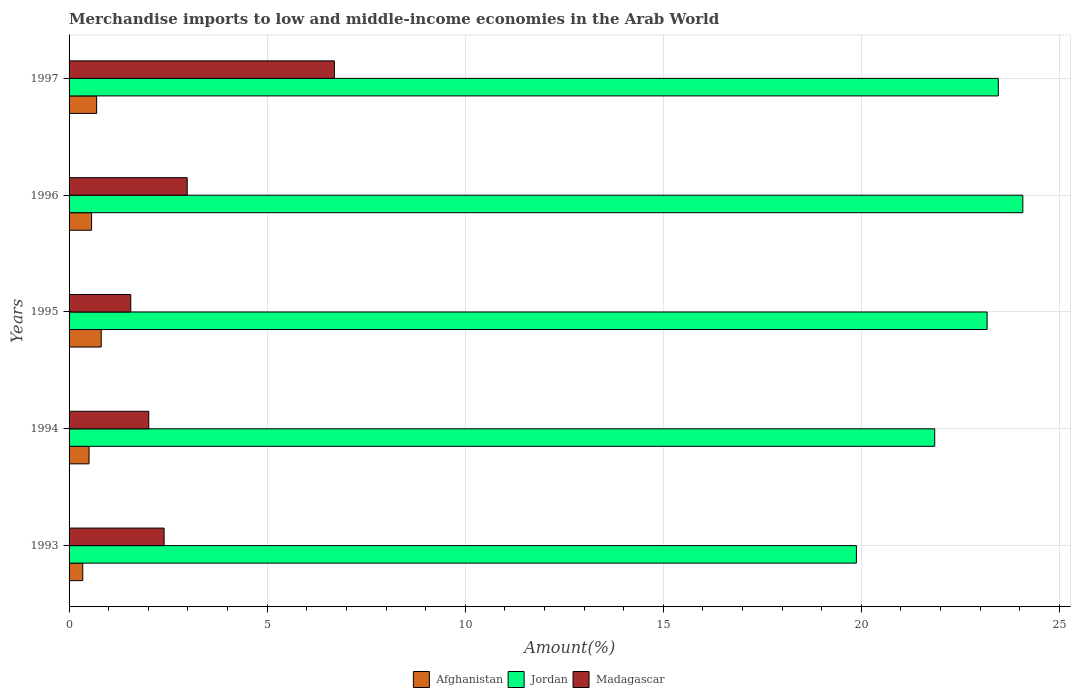Are the number of bars per tick equal to the number of legend labels?
Your response must be concise. Yes. In how many cases, is the number of bars for a given year not equal to the number of legend labels?
Your response must be concise. 0. What is the percentage of amount earned from merchandise imports in Jordan in 1996?
Offer a terse response. 24.07. Across all years, what is the maximum percentage of amount earned from merchandise imports in Afghanistan?
Provide a short and direct response. 0.81. Across all years, what is the minimum percentage of amount earned from merchandise imports in Madagascar?
Your answer should be very brief. 1.56. In which year was the percentage of amount earned from merchandise imports in Jordan maximum?
Your response must be concise. 1996. What is the total percentage of amount earned from merchandise imports in Madagascar in the graph?
Offer a terse response. 15.65. What is the difference between the percentage of amount earned from merchandise imports in Jordan in 1995 and that in 1996?
Make the answer very short. -0.9. What is the difference between the percentage of amount earned from merchandise imports in Jordan in 1994 and the percentage of amount earned from merchandise imports in Afghanistan in 1996?
Keep it short and to the point. 21.28. What is the average percentage of amount earned from merchandise imports in Jordan per year?
Provide a succinct answer. 22.49. In the year 1994, what is the difference between the percentage of amount earned from merchandise imports in Madagascar and percentage of amount earned from merchandise imports in Jordan?
Make the answer very short. -19.84. In how many years, is the percentage of amount earned from merchandise imports in Jordan greater than 4 %?
Make the answer very short. 5. What is the ratio of the percentage of amount earned from merchandise imports in Afghanistan in 1993 to that in 1996?
Give a very brief answer. 0.61. What is the difference between the highest and the second highest percentage of amount earned from merchandise imports in Jordan?
Your answer should be very brief. 0.62. What is the difference between the highest and the lowest percentage of amount earned from merchandise imports in Afghanistan?
Your response must be concise. 0.47. What does the 2nd bar from the top in 1994 represents?
Give a very brief answer. Jordan. What does the 1st bar from the bottom in 1993 represents?
Provide a short and direct response. Afghanistan. Is it the case that in every year, the sum of the percentage of amount earned from merchandise imports in Afghanistan and percentage of amount earned from merchandise imports in Madagascar is greater than the percentage of amount earned from merchandise imports in Jordan?
Your answer should be compact. No. Are all the bars in the graph horizontal?
Make the answer very short. Yes. How many years are there in the graph?
Give a very brief answer. 5. What is the difference between two consecutive major ticks on the X-axis?
Your answer should be compact. 5. Are the values on the major ticks of X-axis written in scientific E-notation?
Your answer should be very brief. No. Does the graph contain any zero values?
Offer a very short reply. No. Does the graph contain grids?
Make the answer very short. Yes. How are the legend labels stacked?
Offer a terse response. Horizontal. What is the title of the graph?
Provide a succinct answer. Merchandise imports to low and middle-income economies in the Arab World. What is the label or title of the X-axis?
Your answer should be compact. Amount(%). What is the Amount(%) of Afghanistan in 1993?
Give a very brief answer. 0.35. What is the Amount(%) of Jordan in 1993?
Provide a succinct answer. 19.87. What is the Amount(%) in Madagascar in 1993?
Make the answer very short. 2.4. What is the Amount(%) of Afghanistan in 1994?
Offer a very short reply. 0.5. What is the Amount(%) in Jordan in 1994?
Provide a succinct answer. 21.85. What is the Amount(%) of Madagascar in 1994?
Keep it short and to the point. 2.01. What is the Amount(%) in Afghanistan in 1995?
Keep it short and to the point. 0.81. What is the Amount(%) in Jordan in 1995?
Your response must be concise. 23.17. What is the Amount(%) of Madagascar in 1995?
Give a very brief answer. 1.56. What is the Amount(%) of Afghanistan in 1996?
Offer a very short reply. 0.57. What is the Amount(%) of Jordan in 1996?
Provide a short and direct response. 24.07. What is the Amount(%) in Madagascar in 1996?
Provide a succinct answer. 2.98. What is the Amount(%) in Afghanistan in 1997?
Keep it short and to the point. 0.7. What is the Amount(%) in Jordan in 1997?
Keep it short and to the point. 23.46. What is the Amount(%) in Madagascar in 1997?
Provide a short and direct response. 6.7. Across all years, what is the maximum Amount(%) in Afghanistan?
Offer a terse response. 0.81. Across all years, what is the maximum Amount(%) of Jordan?
Your answer should be compact. 24.07. Across all years, what is the maximum Amount(%) in Madagascar?
Offer a very short reply. 6.7. Across all years, what is the minimum Amount(%) of Afghanistan?
Your response must be concise. 0.35. Across all years, what is the minimum Amount(%) of Jordan?
Make the answer very short. 19.87. Across all years, what is the minimum Amount(%) in Madagascar?
Ensure brevity in your answer.  1.56. What is the total Amount(%) of Afghanistan in the graph?
Give a very brief answer. 2.93. What is the total Amount(%) in Jordan in the graph?
Ensure brevity in your answer.  112.43. What is the total Amount(%) in Madagascar in the graph?
Ensure brevity in your answer.  15.65. What is the difference between the Amount(%) in Afghanistan in 1993 and that in 1994?
Make the answer very short. -0.16. What is the difference between the Amount(%) of Jordan in 1993 and that in 1994?
Provide a short and direct response. -1.98. What is the difference between the Amount(%) in Madagascar in 1993 and that in 1994?
Keep it short and to the point. 0.39. What is the difference between the Amount(%) of Afghanistan in 1993 and that in 1995?
Make the answer very short. -0.47. What is the difference between the Amount(%) of Jordan in 1993 and that in 1995?
Ensure brevity in your answer.  -3.3. What is the difference between the Amount(%) in Madagascar in 1993 and that in 1995?
Your answer should be very brief. 0.84. What is the difference between the Amount(%) of Afghanistan in 1993 and that in 1996?
Make the answer very short. -0.22. What is the difference between the Amount(%) in Jordan in 1993 and that in 1996?
Keep it short and to the point. -4.2. What is the difference between the Amount(%) in Madagascar in 1993 and that in 1996?
Provide a succinct answer. -0.58. What is the difference between the Amount(%) in Afghanistan in 1993 and that in 1997?
Provide a short and direct response. -0.35. What is the difference between the Amount(%) in Jordan in 1993 and that in 1997?
Keep it short and to the point. -3.58. What is the difference between the Amount(%) of Madagascar in 1993 and that in 1997?
Give a very brief answer. -4.3. What is the difference between the Amount(%) of Afghanistan in 1994 and that in 1995?
Provide a succinct answer. -0.31. What is the difference between the Amount(%) of Jordan in 1994 and that in 1995?
Ensure brevity in your answer.  -1.32. What is the difference between the Amount(%) in Madagascar in 1994 and that in 1995?
Provide a succinct answer. 0.45. What is the difference between the Amount(%) in Afghanistan in 1994 and that in 1996?
Provide a short and direct response. -0.06. What is the difference between the Amount(%) of Jordan in 1994 and that in 1996?
Offer a very short reply. -2.22. What is the difference between the Amount(%) of Madagascar in 1994 and that in 1996?
Offer a terse response. -0.97. What is the difference between the Amount(%) of Afghanistan in 1994 and that in 1997?
Your answer should be compact. -0.19. What is the difference between the Amount(%) of Jordan in 1994 and that in 1997?
Offer a terse response. -1.6. What is the difference between the Amount(%) in Madagascar in 1994 and that in 1997?
Offer a terse response. -4.69. What is the difference between the Amount(%) of Afghanistan in 1995 and that in 1996?
Give a very brief answer. 0.24. What is the difference between the Amount(%) of Jordan in 1995 and that in 1996?
Offer a very short reply. -0.9. What is the difference between the Amount(%) of Madagascar in 1995 and that in 1996?
Provide a succinct answer. -1.42. What is the difference between the Amount(%) of Afghanistan in 1995 and that in 1997?
Provide a short and direct response. 0.12. What is the difference between the Amount(%) of Jordan in 1995 and that in 1997?
Provide a succinct answer. -0.28. What is the difference between the Amount(%) in Madagascar in 1995 and that in 1997?
Your answer should be very brief. -5.14. What is the difference between the Amount(%) of Afghanistan in 1996 and that in 1997?
Make the answer very short. -0.13. What is the difference between the Amount(%) in Jordan in 1996 and that in 1997?
Provide a short and direct response. 0.62. What is the difference between the Amount(%) of Madagascar in 1996 and that in 1997?
Provide a short and direct response. -3.72. What is the difference between the Amount(%) of Afghanistan in 1993 and the Amount(%) of Jordan in 1994?
Provide a short and direct response. -21.51. What is the difference between the Amount(%) in Afghanistan in 1993 and the Amount(%) in Madagascar in 1994?
Give a very brief answer. -1.67. What is the difference between the Amount(%) in Jordan in 1993 and the Amount(%) in Madagascar in 1994?
Your answer should be very brief. 17.86. What is the difference between the Amount(%) in Afghanistan in 1993 and the Amount(%) in Jordan in 1995?
Keep it short and to the point. -22.83. What is the difference between the Amount(%) of Afghanistan in 1993 and the Amount(%) of Madagascar in 1995?
Keep it short and to the point. -1.21. What is the difference between the Amount(%) of Jordan in 1993 and the Amount(%) of Madagascar in 1995?
Your response must be concise. 18.32. What is the difference between the Amount(%) in Afghanistan in 1993 and the Amount(%) in Jordan in 1996?
Make the answer very short. -23.73. What is the difference between the Amount(%) in Afghanistan in 1993 and the Amount(%) in Madagascar in 1996?
Provide a succinct answer. -2.64. What is the difference between the Amount(%) of Jordan in 1993 and the Amount(%) of Madagascar in 1996?
Provide a short and direct response. 16.89. What is the difference between the Amount(%) of Afghanistan in 1993 and the Amount(%) of Jordan in 1997?
Ensure brevity in your answer.  -23.11. What is the difference between the Amount(%) in Afghanistan in 1993 and the Amount(%) in Madagascar in 1997?
Offer a terse response. -6.35. What is the difference between the Amount(%) of Jordan in 1993 and the Amount(%) of Madagascar in 1997?
Offer a very short reply. 13.18. What is the difference between the Amount(%) in Afghanistan in 1994 and the Amount(%) in Jordan in 1995?
Give a very brief answer. -22.67. What is the difference between the Amount(%) in Afghanistan in 1994 and the Amount(%) in Madagascar in 1995?
Provide a short and direct response. -1.05. What is the difference between the Amount(%) in Jordan in 1994 and the Amount(%) in Madagascar in 1995?
Make the answer very short. 20.29. What is the difference between the Amount(%) of Afghanistan in 1994 and the Amount(%) of Jordan in 1996?
Provide a succinct answer. -23.57. What is the difference between the Amount(%) in Afghanistan in 1994 and the Amount(%) in Madagascar in 1996?
Your answer should be very brief. -2.48. What is the difference between the Amount(%) in Jordan in 1994 and the Amount(%) in Madagascar in 1996?
Your response must be concise. 18.87. What is the difference between the Amount(%) in Afghanistan in 1994 and the Amount(%) in Jordan in 1997?
Make the answer very short. -22.95. What is the difference between the Amount(%) in Afghanistan in 1994 and the Amount(%) in Madagascar in 1997?
Ensure brevity in your answer.  -6.19. What is the difference between the Amount(%) of Jordan in 1994 and the Amount(%) of Madagascar in 1997?
Offer a very short reply. 15.15. What is the difference between the Amount(%) of Afghanistan in 1995 and the Amount(%) of Jordan in 1996?
Your response must be concise. -23.26. What is the difference between the Amount(%) in Afghanistan in 1995 and the Amount(%) in Madagascar in 1996?
Give a very brief answer. -2.17. What is the difference between the Amount(%) in Jordan in 1995 and the Amount(%) in Madagascar in 1996?
Offer a terse response. 20.19. What is the difference between the Amount(%) in Afghanistan in 1995 and the Amount(%) in Jordan in 1997?
Provide a succinct answer. -22.64. What is the difference between the Amount(%) of Afghanistan in 1995 and the Amount(%) of Madagascar in 1997?
Your answer should be very brief. -5.89. What is the difference between the Amount(%) of Jordan in 1995 and the Amount(%) of Madagascar in 1997?
Your response must be concise. 16.48. What is the difference between the Amount(%) of Afghanistan in 1996 and the Amount(%) of Jordan in 1997?
Offer a very short reply. -22.89. What is the difference between the Amount(%) of Afghanistan in 1996 and the Amount(%) of Madagascar in 1997?
Your answer should be compact. -6.13. What is the difference between the Amount(%) of Jordan in 1996 and the Amount(%) of Madagascar in 1997?
Your response must be concise. 17.38. What is the average Amount(%) in Afghanistan per year?
Offer a terse response. 0.59. What is the average Amount(%) of Jordan per year?
Give a very brief answer. 22.49. What is the average Amount(%) of Madagascar per year?
Your answer should be very brief. 3.13. In the year 1993, what is the difference between the Amount(%) of Afghanistan and Amount(%) of Jordan?
Give a very brief answer. -19.53. In the year 1993, what is the difference between the Amount(%) of Afghanistan and Amount(%) of Madagascar?
Your answer should be compact. -2.05. In the year 1993, what is the difference between the Amount(%) in Jordan and Amount(%) in Madagascar?
Keep it short and to the point. 17.48. In the year 1994, what is the difference between the Amount(%) of Afghanistan and Amount(%) of Jordan?
Ensure brevity in your answer.  -21.35. In the year 1994, what is the difference between the Amount(%) of Afghanistan and Amount(%) of Madagascar?
Your answer should be compact. -1.51. In the year 1994, what is the difference between the Amount(%) of Jordan and Amount(%) of Madagascar?
Your answer should be very brief. 19.84. In the year 1995, what is the difference between the Amount(%) in Afghanistan and Amount(%) in Jordan?
Provide a succinct answer. -22.36. In the year 1995, what is the difference between the Amount(%) in Afghanistan and Amount(%) in Madagascar?
Make the answer very short. -0.75. In the year 1995, what is the difference between the Amount(%) in Jordan and Amount(%) in Madagascar?
Offer a very short reply. 21.62. In the year 1996, what is the difference between the Amount(%) in Afghanistan and Amount(%) in Jordan?
Provide a short and direct response. -23.51. In the year 1996, what is the difference between the Amount(%) in Afghanistan and Amount(%) in Madagascar?
Give a very brief answer. -2.41. In the year 1996, what is the difference between the Amount(%) in Jordan and Amount(%) in Madagascar?
Keep it short and to the point. 21.09. In the year 1997, what is the difference between the Amount(%) of Afghanistan and Amount(%) of Jordan?
Your answer should be compact. -22.76. In the year 1997, what is the difference between the Amount(%) of Afghanistan and Amount(%) of Madagascar?
Your answer should be very brief. -6. In the year 1997, what is the difference between the Amount(%) in Jordan and Amount(%) in Madagascar?
Your answer should be compact. 16.76. What is the ratio of the Amount(%) in Afghanistan in 1993 to that in 1994?
Provide a short and direct response. 0.69. What is the ratio of the Amount(%) of Jordan in 1993 to that in 1994?
Your answer should be very brief. 0.91. What is the ratio of the Amount(%) of Madagascar in 1993 to that in 1994?
Your response must be concise. 1.19. What is the ratio of the Amount(%) of Afghanistan in 1993 to that in 1995?
Give a very brief answer. 0.43. What is the ratio of the Amount(%) of Jordan in 1993 to that in 1995?
Provide a succinct answer. 0.86. What is the ratio of the Amount(%) of Madagascar in 1993 to that in 1995?
Make the answer very short. 1.54. What is the ratio of the Amount(%) in Afghanistan in 1993 to that in 1996?
Ensure brevity in your answer.  0.61. What is the ratio of the Amount(%) of Jordan in 1993 to that in 1996?
Provide a short and direct response. 0.83. What is the ratio of the Amount(%) in Madagascar in 1993 to that in 1996?
Ensure brevity in your answer.  0.8. What is the ratio of the Amount(%) of Afghanistan in 1993 to that in 1997?
Your answer should be compact. 0.5. What is the ratio of the Amount(%) in Jordan in 1993 to that in 1997?
Your answer should be compact. 0.85. What is the ratio of the Amount(%) in Madagascar in 1993 to that in 1997?
Your answer should be very brief. 0.36. What is the ratio of the Amount(%) in Afghanistan in 1994 to that in 1995?
Give a very brief answer. 0.62. What is the ratio of the Amount(%) of Jordan in 1994 to that in 1995?
Your answer should be very brief. 0.94. What is the ratio of the Amount(%) of Madagascar in 1994 to that in 1995?
Your response must be concise. 1.29. What is the ratio of the Amount(%) of Afghanistan in 1994 to that in 1996?
Ensure brevity in your answer.  0.89. What is the ratio of the Amount(%) of Jordan in 1994 to that in 1996?
Keep it short and to the point. 0.91. What is the ratio of the Amount(%) of Madagascar in 1994 to that in 1996?
Your response must be concise. 0.67. What is the ratio of the Amount(%) in Afghanistan in 1994 to that in 1997?
Your answer should be compact. 0.73. What is the ratio of the Amount(%) in Jordan in 1994 to that in 1997?
Your answer should be compact. 0.93. What is the ratio of the Amount(%) in Madagascar in 1994 to that in 1997?
Provide a short and direct response. 0.3. What is the ratio of the Amount(%) in Afghanistan in 1995 to that in 1996?
Your answer should be compact. 1.43. What is the ratio of the Amount(%) in Jordan in 1995 to that in 1996?
Offer a very short reply. 0.96. What is the ratio of the Amount(%) of Madagascar in 1995 to that in 1996?
Give a very brief answer. 0.52. What is the ratio of the Amount(%) in Afghanistan in 1995 to that in 1997?
Offer a terse response. 1.17. What is the ratio of the Amount(%) of Jordan in 1995 to that in 1997?
Provide a short and direct response. 0.99. What is the ratio of the Amount(%) of Madagascar in 1995 to that in 1997?
Offer a terse response. 0.23. What is the ratio of the Amount(%) of Afghanistan in 1996 to that in 1997?
Offer a very short reply. 0.82. What is the ratio of the Amount(%) in Jordan in 1996 to that in 1997?
Make the answer very short. 1.03. What is the ratio of the Amount(%) in Madagascar in 1996 to that in 1997?
Provide a succinct answer. 0.45. What is the difference between the highest and the second highest Amount(%) in Afghanistan?
Offer a terse response. 0.12. What is the difference between the highest and the second highest Amount(%) in Jordan?
Your answer should be compact. 0.62. What is the difference between the highest and the second highest Amount(%) in Madagascar?
Your answer should be very brief. 3.72. What is the difference between the highest and the lowest Amount(%) of Afghanistan?
Your response must be concise. 0.47. What is the difference between the highest and the lowest Amount(%) of Jordan?
Offer a terse response. 4.2. What is the difference between the highest and the lowest Amount(%) of Madagascar?
Offer a very short reply. 5.14. 